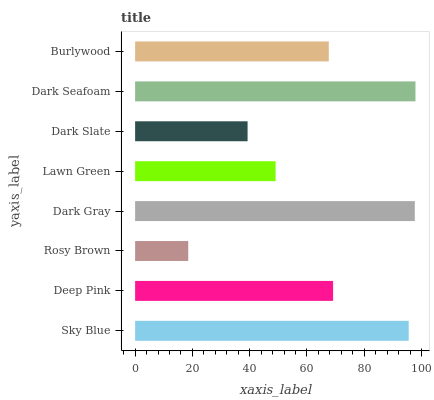Is Rosy Brown the minimum?
Answer yes or no. Yes. Is Dark Seafoam the maximum?
Answer yes or no. Yes. Is Deep Pink the minimum?
Answer yes or no. No. Is Deep Pink the maximum?
Answer yes or no. No. Is Sky Blue greater than Deep Pink?
Answer yes or no. Yes. Is Deep Pink less than Sky Blue?
Answer yes or no. Yes. Is Deep Pink greater than Sky Blue?
Answer yes or no. No. Is Sky Blue less than Deep Pink?
Answer yes or no. No. Is Deep Pink the high median?
Answer yes or no. Yes. Is Burlywood the low median?
Answer yes or no. Yes. Is Sky Blue the high median?
Answer yes or no. No. Is Lawn Green the low median?
Answer yes or no. No. 